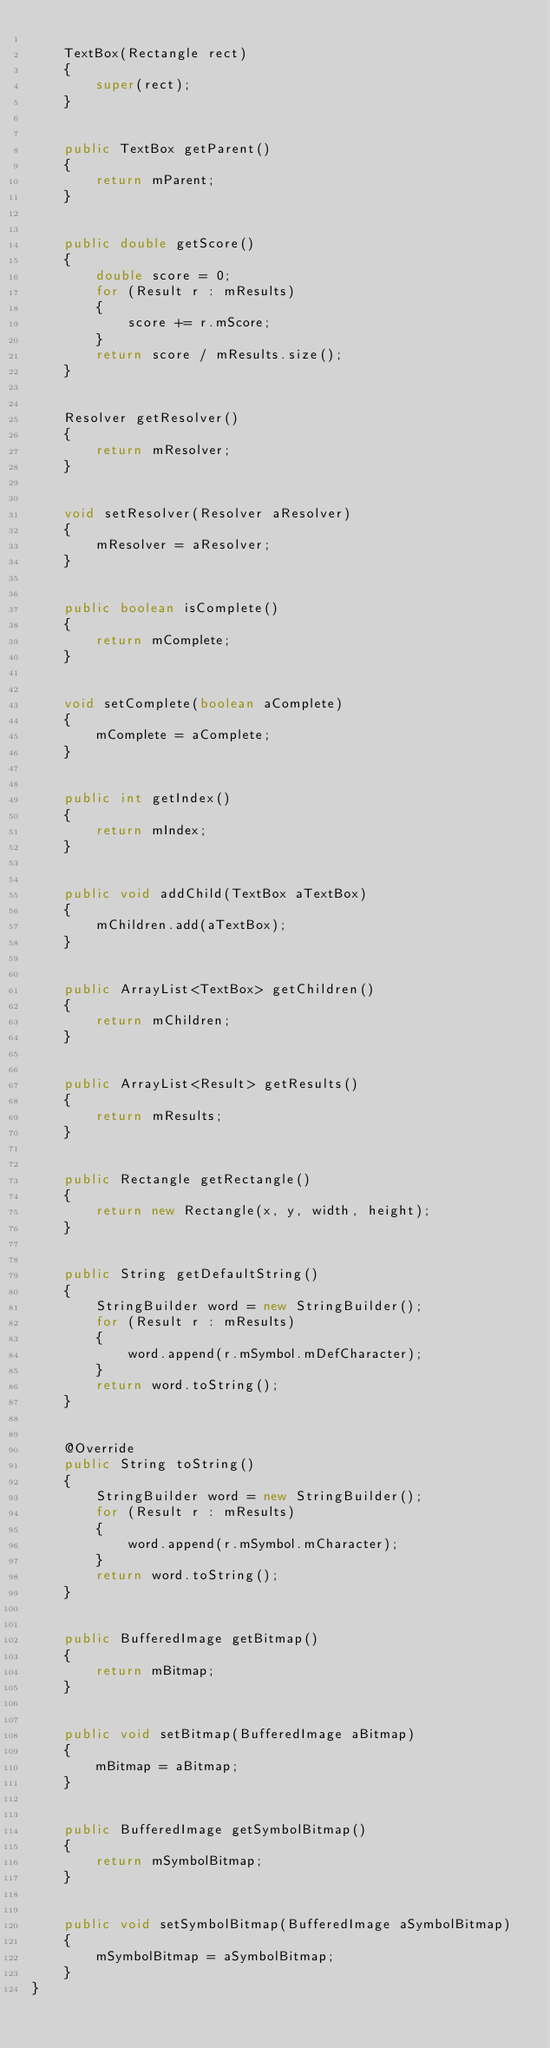Convert code to text. <code><loc_0><loc_0><loc_500><loc_500><_Java_>
	TextBox(Rectangle rect)
	{
		super(rect);
	}


	public TextBox getParent()
	{
		return mParent;
	}


	public double getScore()
	{
		double score = 0;
		for (Result r : mResults)
		{
			score += r.mScore;
		}
		return score / mResults.size();
	}


	Resolver getResolver()
	{
		return mResolver;
	}


	void setResolver(Resolver aResolver)
	{
		mResolver = aResolver;
	}


	public boolean isComplete()
	{
		return mComplete;
	}


	void setComplete(boolean aComplete)
	{
		mComplete = aComplete;
	}


	public int getIndex()
	{
		return mIndex;
	}


	public void addChild(TextBox aTextBox)
	{
		mChildren.add(aTextBox);
	}


	public ArrayList<TextBox> getChildren()
	{
		return mChildren;
	}


	public ArrayList<Result> getResults()
	{
		return mResults;
	}


	public Rectangle getRectangle()
	{
		return new Rectangle(x, y, width, height);
	}


	public String getDefaultString()
	{
		StringBuilder word = new StringBuilder();
		for (Result r : mResults)
		{
			word.append(r.mSymbol.mDefCharacter);
		}
		return word.toString();
	}


	@Override
	public String toString()
	{
		StringBuilder word = new StringBuilder();
		for (Result r : mResults)
		{
			word.append(r.mSymbol.mCharacter);
		}
		return word.toString();
	}


	public BufferedImage getBitmap()
	{
		return mBitmap;
	}


	public void setBitmap(BufferedImage aBitmap)
	{
		mBitmap = aBitmap;
	}


	public BufferedImage getSymbolBitmap()
	{
		return mSymbolBitmap;
	}


	public void setSymbolBitmap(BufferedImage aSymbolBitmap)
	{
		mSymbolBitmap = aSymbolBitmap;
	}
}</code> 